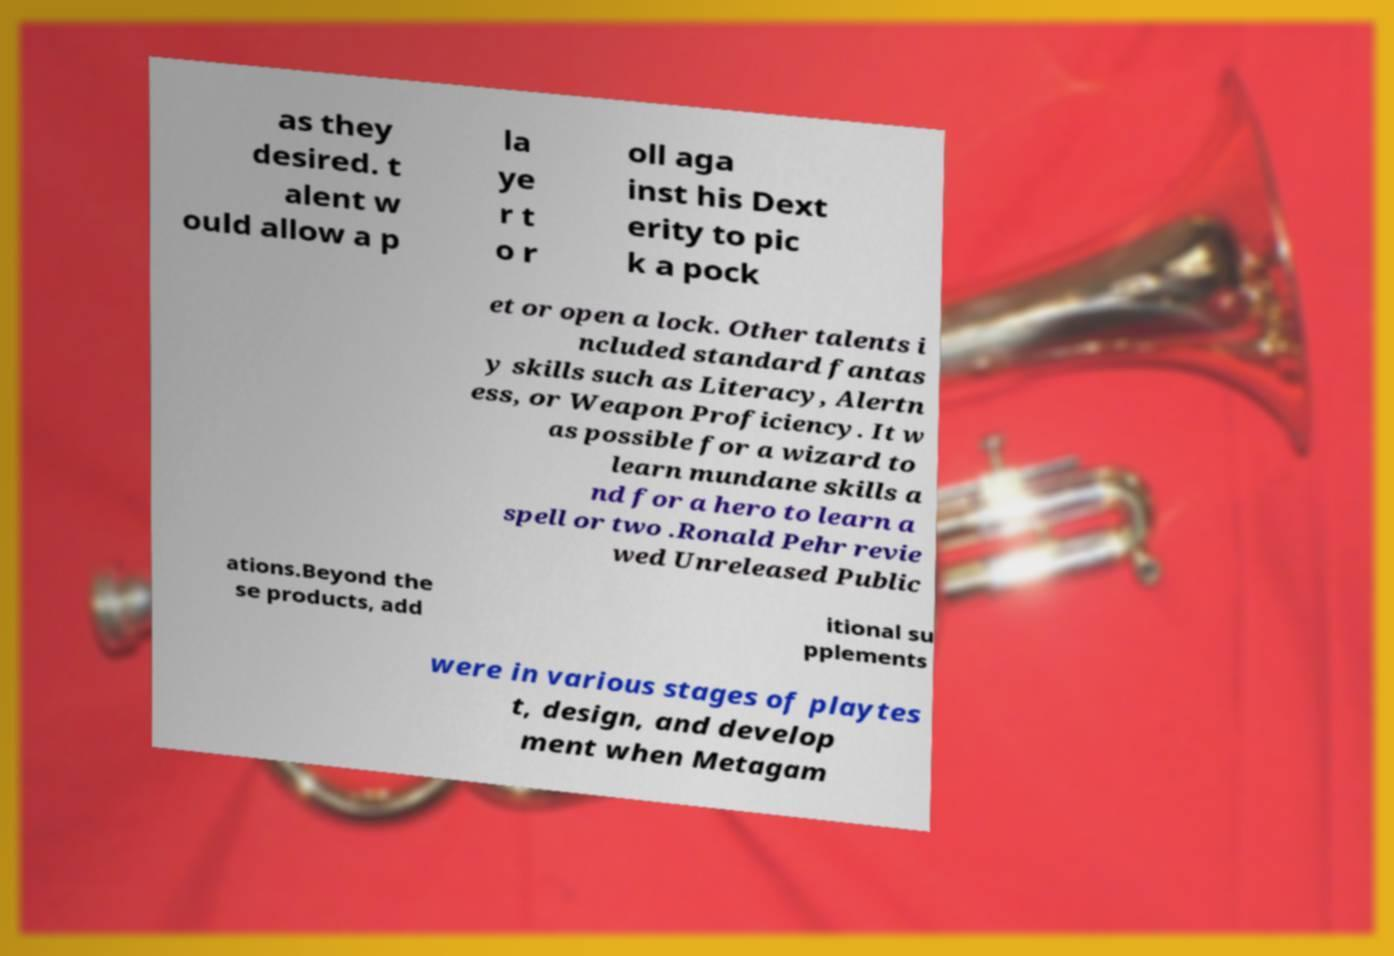I need the written content from this picture converted into text. Can you do that? as they desired. t alent w ould allow a p la ye r t o r oll aga inst his Dext erity to pic k a pock et or open a lock. Other talents i ncluded standard fantas y skills such as Literacy, Alertn ess, or Weapon Proficiency. It w as possible for a wizard to learn mundane skills a nd for a hero to learn a spell or two .Ronald Pehr revie wed Unreleased Public ations.Beyond the se products, add itional su pplements were in various stages of playtes t, design, and develop ment when Metagam 